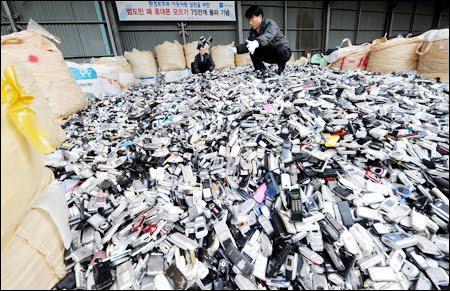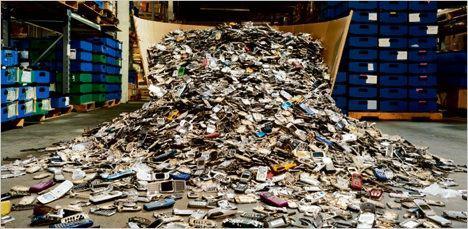The first image is the image on the left, the second image is the image on the right. For the images shown, is this caption "There are cell phone being pushed off a metal shelve to land on a conveyor belt." true? Answer yes or no. No. The first image is the image on the left, the second image is the image on the right. For the images shown, is this caption "There is exactly one person in the left image." true? Answer yes or no. No. 